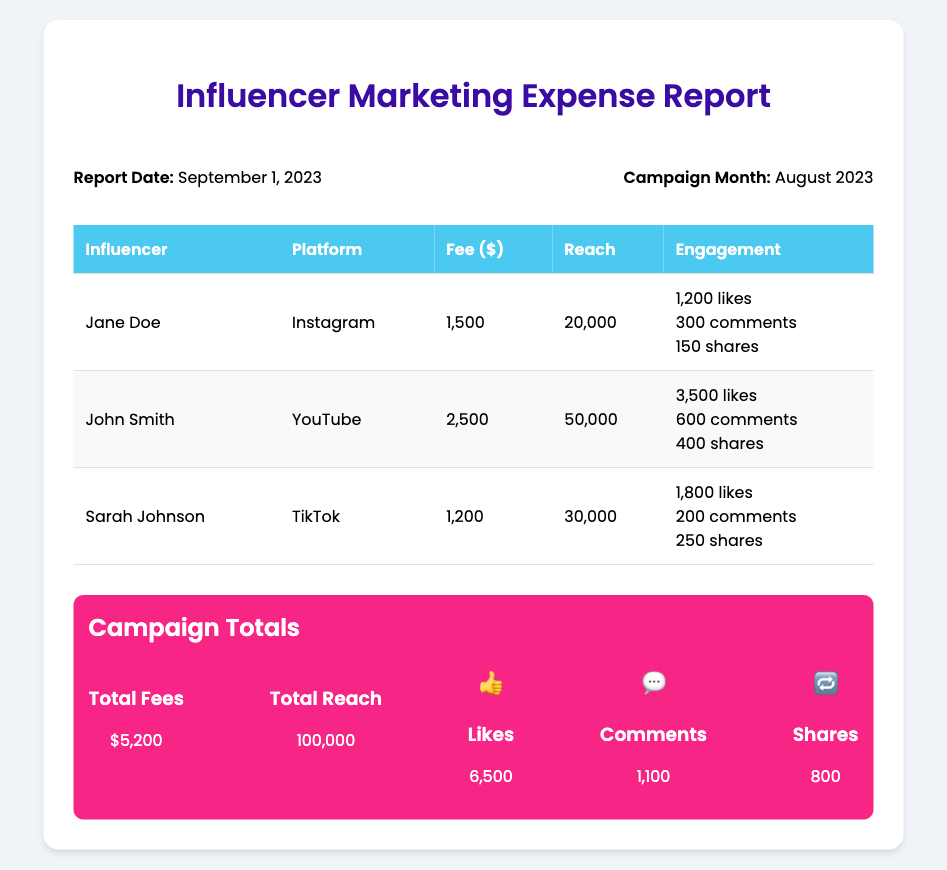What is the report date? The report date is explicitly mentioned in the document, which is September 1, 2023.
Answer: September 1, 2023 What is the total fee for influencer collaborations? The total fee is calculated by summing the individual fees from all influencers listed in the document, which is $1,500 + $2,500 + $1,200 = $5,200.
Answer: $5,200 Who is the influencer on TikTok? The document lists Sarah Johnson as the influencer associated with TikTok.
Answer: Sarah Johnson What is the reach of John Smith on YouTube? The reach for John Smith is directly provided in the document as 50,000.
Answer: 50,000 How many likes did Sarah Johnson receive? The document provides the likes for Sarah Johnson as part of her engagement metrics, specifically 1,800 likes.
Answer: 1,800 What is the total reach across all influencers? The total reach is provided in the summary section, which is the sum of all individual reach values: 20,000 + 50,000 + 30,000 = 100,000.
Answer: 100,000 What platform does Jane Doe use? The document specifies that Jane Doe is on Instagram.
Answer: Instagram What is the total number of shares across all influencers? The total number of shares is the cumulative total from all influencers given in the document: 150 + 400 + 250 = 800.
Answer: 800 What are the total comments across all influencers? The total comments are explicitly calculated by combining each influencer's comments: 300 + 600 + 200 = 1,100.
Answer: 1,100 